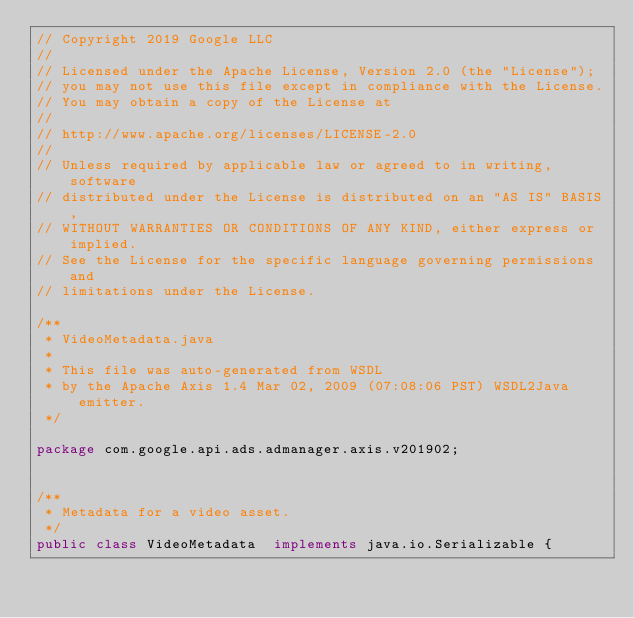<code> <loc_0><loc_0><loc_500><loc_500><_Java_>// Copyright 2019 Google LLC
//
// Licensed under the Apache License, Version 2.0 (the "License");
// you may not use this file except in compliance with the License.
// You may obtain a copy of the License at
//
// http://www.apache.org/licenses/LICENSE-2.0
//
// Unless required by applicable law or agreed to in writing, software
// distributed under the License is distributed on an "AS IS" BASIS,
// WITHOUT WARRANTIES OR CONDITIONS OF ANY KIND, either express or implied.
// See the License for the specific language governing permissions and
// limitations under the License.

/**
 * VideoMetadata.java
 *
 * This file was auto-generated from WSDL
 * by the Apache Axis 1.4 Mar 02, 2009 (07:08:06 PST) WSDL2Java emitter.
 */

package com.google.api.ads.admanager.axis.v201902;


/**
 * Metadata for a video asset.
 */
public class VideoMetadata  implements java.io.Serializable {</code> 